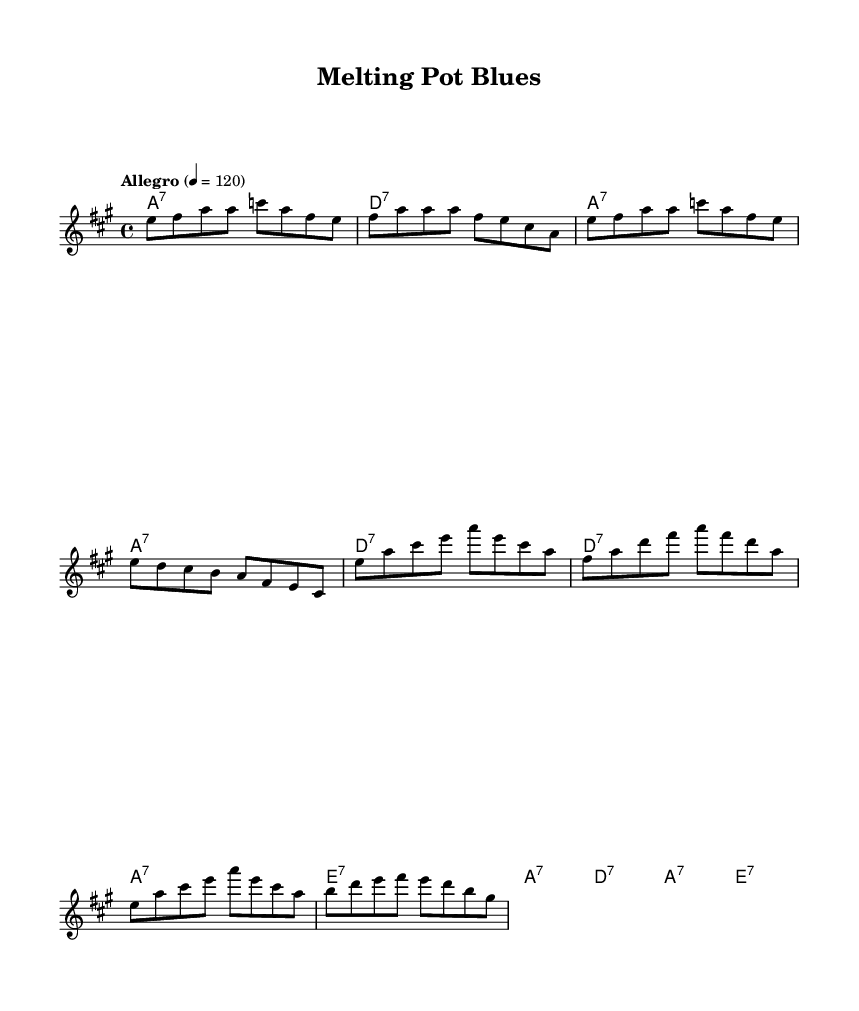What is the key signature of this music? The key signature shown at the beginning of the piece indicates that it is set in A major, which features three sharps (F#, C#, and G#).
Answer: A major What is the time signature of this music? The time signature indicated on the sheet music is 4/4, which signifies that there are four beats in each measure and that the quarter note receives one beat.
Answer: 4/4 What is the tempo marking for this piece? The tempo marking stated in the sheet music is "Allegro" with a metronome marking of 120 beats per minute, suggesting a fast and lively pace.
Answer: Allegro, 120 How many measures are in the verse? The verse section contains four measures as indicated by the grouping of four sets of notes that are divided by vertical lines (bar lines).
Answer: Four What chords are used in the chorus? The chords listed in the chord section for the chorus are E, A, and D major seventh chords. This suggests a sequence that enhances the harmony characteristic of electric blues music.
Answer: E7, A7, D7 What is the main theme celebrated in the lyrics of this piece? The lyrics celebrate diversity and multiculturalism, as they refer to different cultures coming together to create a "melting pot" environment filled with hopes, dreams, and unity.
Answer: Diversity and multiculturalism How does the structure of the song reflect electric blues traditions? The song follows a typical 12-bar progression format common in electric blues, using dominant seventh chords that are characteristic of the genre, enhancing the overall bluesy sound and feel.
Answer: 12-bar progression with seventh chords 